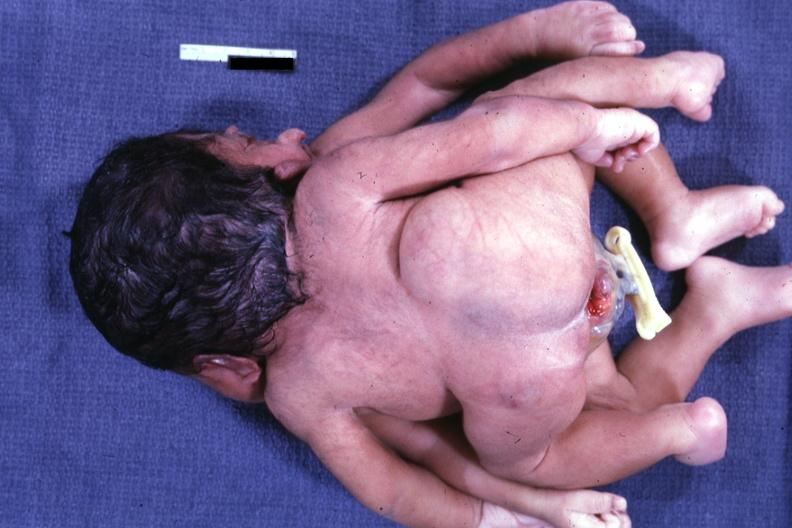what does this image show?
Answer the question using a single word or phrase. View of twin joined at head and chest 